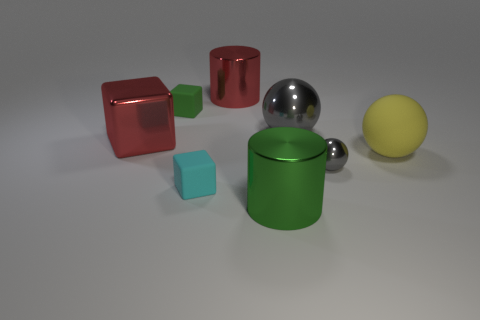Add 2 cyan rubber blocks. How many objects exist? 10 Subtract all cubes. How many objects are left? 5 Add 1 large rubber objects. How many large rubber objects are left? 2 Add 5 brown shiny blocks. How many brown shiny blocks exist? 5 Subtract 0 blue spheres. How many objects are left? 8 Subtract all big green rubber balls. Subtract all tiny matte objects. How many objects are left? 6 